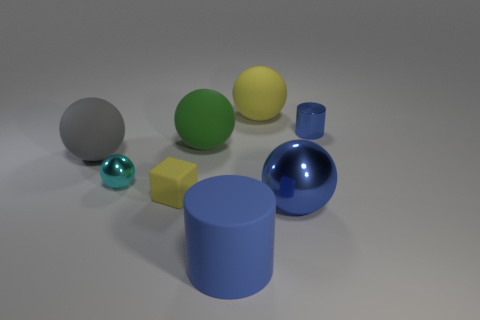Subtract all big green balls. How many balls are left? 4 Subtract all blocks. How many objects are left? 7 Subtract 2 spheres. How many spheres are left? 3 Subtract all cyan spheres. How many spheres are left? 4 Subtract all small brown shiny objects. Subtract all large blue cylinders. How many objects are left? 7 Add 5 balls. How many balls are left? 10 Add 6 shiny cylinders. How many shiny cylinders exist? 7 Add 2 red cubes. How many objects exist? 10 Subtract 0 green cylinders. How many objects are left? 8 Subtract all purple cubes. Subtract all yellow cylinders. How many cubes are left? 1 